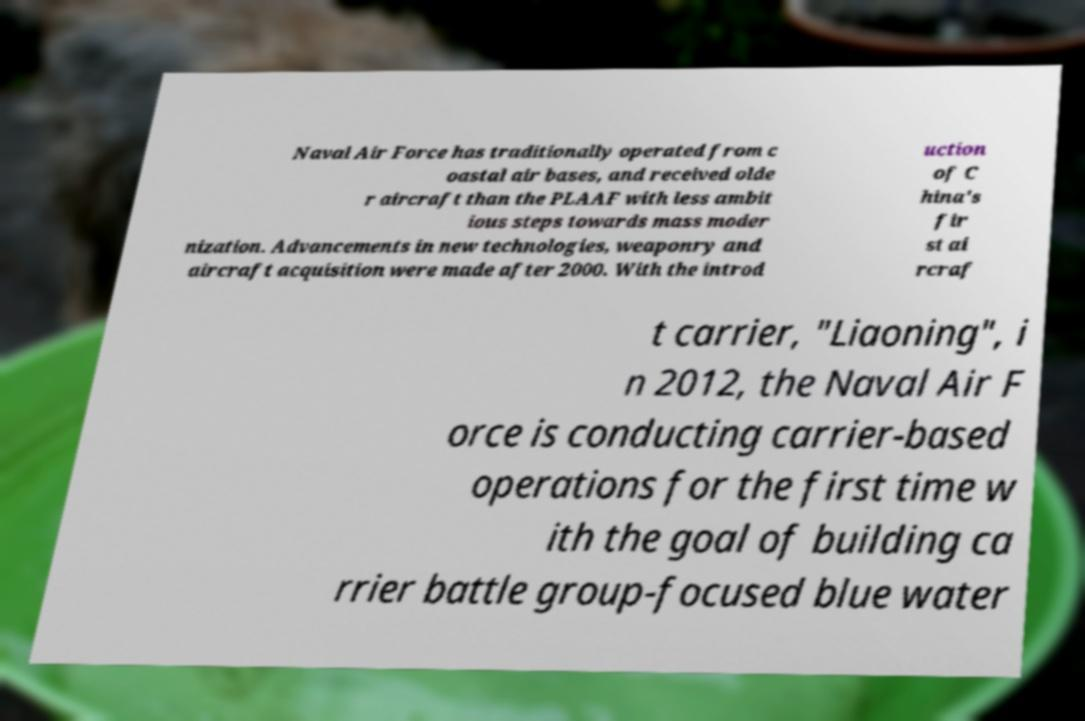Can you accurately transcribe the text from the provided image for me? Naval Air Force has traditionally operated from c oastal air bases, and received olde r aircraft than the PLAAF with less ambit ious steps towards mass moder nization. Advancements in new technologies, weaponry and aircraft acquisition were made after 2000. With the introd uction of C hina's fir st ai rcraf t carrier, "Liaoning", i n 2012, the Naval Air F orce is conducting carrier-based operations for the first time w ith the goal of building ca rrier battle group-focused blue water 